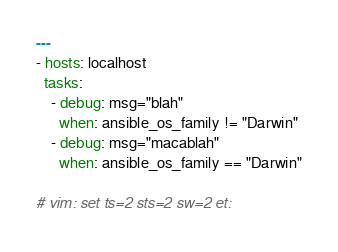Convert code to text. <code><loc_0><loc_0><loc_500><loc_500><_YAML_>---
- hosts: localhost
  tasks:
    - debug: msg="blah"
      when: ansible_os_family != "Darwin"
    - debug: msg="macablah"
      when: ansible_os_family == "Darwin"

# vim: set ts=2 sts=2 sw=2 et:
</code> 